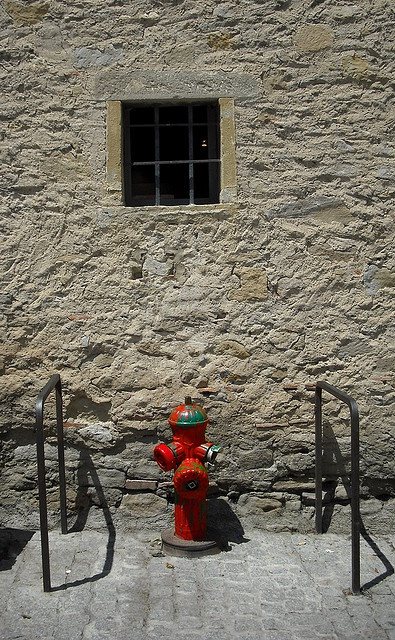Describe the objects in this image and their specific colors. I can see a fire hydrant in darkgray, maroon, black, and red tones in this image. 